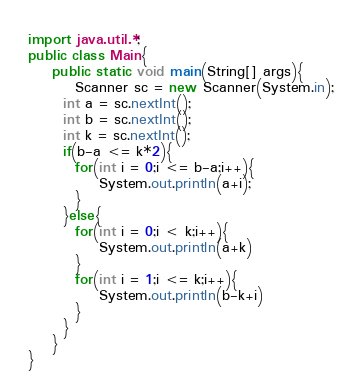<code> <loc_0><loc_0><loc_500><loc_500><_Java_>import java.util.*;
public class Main{
	public static void main(String[] args){
    	Scanner sc = new Scanner(System.in);
      int a = sc.nextInt();
      int b = sc.nextInt();
      int k = sc.nextInt();
      if(b-a <= k*2){
      	for(int i = 0;i <= b-a;i++){
        	System.out.println(a+i);
        }
      }else{
      	for(int i = 0;i < k;i++){
      		System.out.println(a+k)
      	}
      	for(int i = 1;i <= k;i++){
      		System.out.println(b-k+i)
      	}
      }
    }
}</code> 